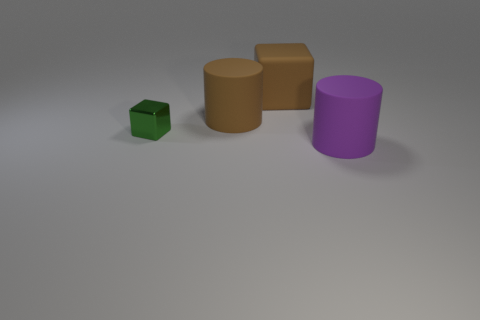Is there anything else that has the same size as the metal thing?
Your answer should be compact. No. Do the large thing behind the brown cylinder and the thing in front of the small object have the same shape?
Your response must be concise. No. How many rubber objects are behind the large purple rubber object and in front of the matte block?
Give a very brief answer. 1. What number of other things are there of the same size as the purple matte cylinder?
Ensure brevity in your answer.  2. There is a large thing that is in front of the large matte cube and left of the large purple object; what material is it?
Keep it short and to the point. Rubber. Do the large cube and the big rubber cylinder in front of the small green cube have the same color?
Give a very brief answer. No. There is a brown rubber thing that is the same shape as the big purple thing; what size is it?
Make the answer very short. Large. What shape is the large rubber thing that is both to the right of the brown cylinder and behind the small thing?
Provide a short and direct response. Cube. Does the green object have the same size as the brown rubber object that is left of the brown block?
Your answer should be very brief. No. What color is the other object that is the same shape as the tiny object?
Your response must be concise. Brown. 